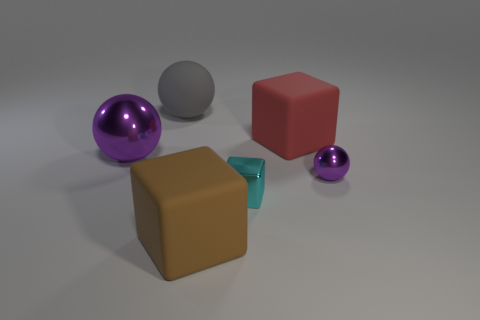Can you describe the objects' arrangement in relation to each other? The objects are placed somewhat casually on a flat surface. The purple reflective sphere is near the foreground, while the small green translucent cube and tiny purple sphere are slightly behind it. The matte red cube and gray sphere are further back, creating a slightly curved diagonal line when we plot the center of each item. 